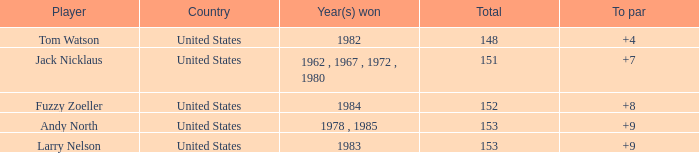What is the To par of Player Andy North with a Total larger than 153? 0.0. 